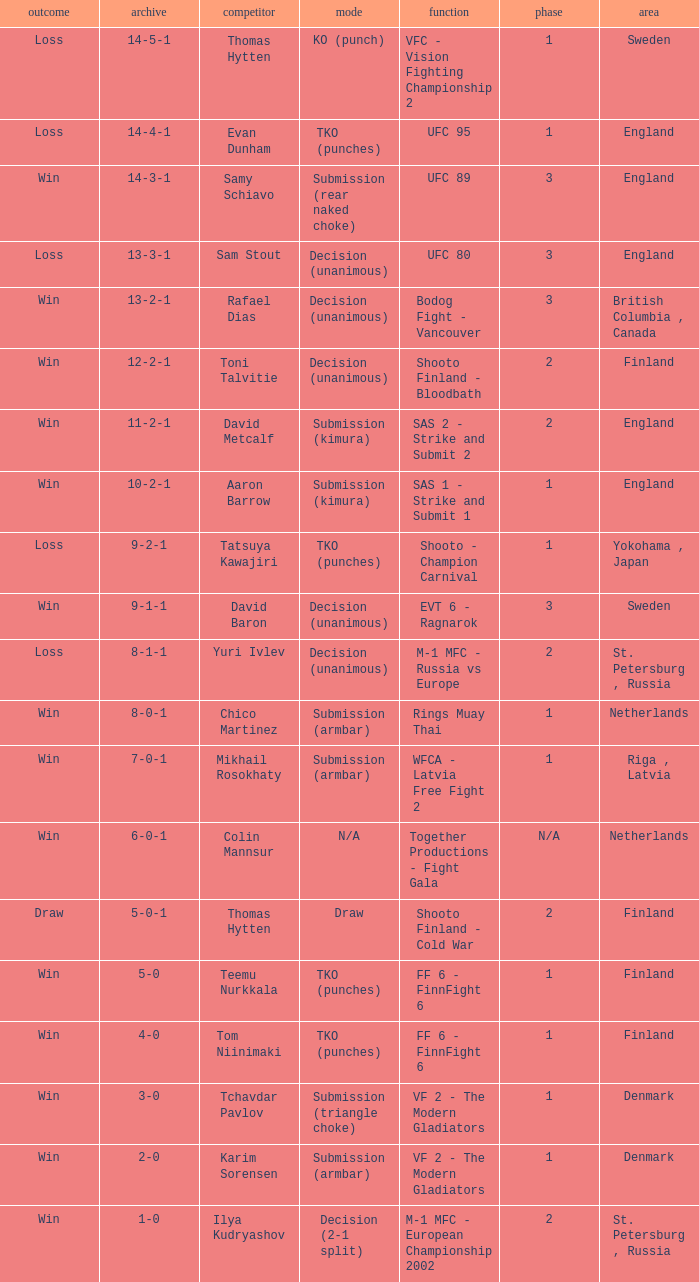What is the round in Finland with a draw for method? 2.0. 